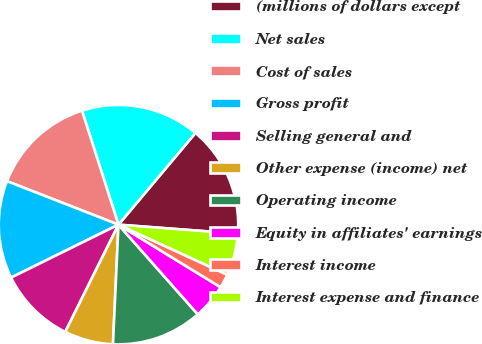Convert chart to OTSL. <chart><loc_0><loc_0><loc_500><loc_500><pie_chart><fcel>(millions of dollars except<fcel>Net sales<fcel>Cost of sales<fcel>Gross profit<fcel>Selling general and<fcel>Other expense (income) net<fcel>Operating income<fcel>Equity in affiliates' earnings<fcel>Interest income<fcel>Interest expense and finance<nl><fcel>15.09%<fcel>16.04%<fcel>14.15%<fcel>13.21%<fcel>10.38%<fcel>6.6%<fcel>12.26%<fcel>4.72%<fcel>1.89%<fcel>5.66%<nl></chart> 